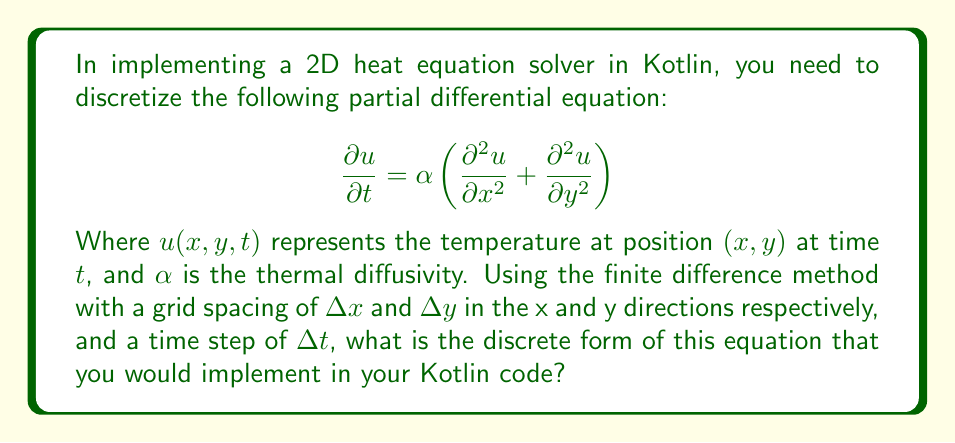Show me your answer to this math problem. To discretize the 2D heat equation, we need to approximate the partial derivatives using finite differences:

1. For the time derivative, we use forward difference:
   $$ \frac{\partial u}{\partial t} \approx \frac{u_{i,j}^{n+1} - u_{i,j}^n}{\Delta t} $$

2. For the spatial derivatives, we use central differences:
   $$ \frac{\partial^2 u}{\partial x^2} \approx \frac{u_{i+1,j}^n - 2u_{i,j}^n + u_{i-1,j}^n}{(\Delta x)^2} $$
   $$ \frac{\partial^2 u}{\partial y^2} \approx \frac{u_{i,j+1}^n - 2u_{i,j}^n + u_{i,j-1}^n}{(\Delta y)^2} $$

3. Substituting these approximations into the original PDE:

   $$ \frac{u_{i,j}^{n+1} - u_{i,j}^n}{\Delta t} = \alpha \left(\frac{u_{i+1,j}^n - 2u_{i,j}^n + u_{i-1,j}^n}{(\Delta x)^2} + \frac{u_{i,j+1}^n - 2u_{i,j}^n + u_{i,j-1}^n}{(\Delta y)^2}\right) $$

4. Rearranging to solve for $u_{i,j}^{n+1}$:

   $$ u_{i,j}^{n+1} = u_{i,j}^n + \alpha \Delta t \left(\frac{u_{i+1,j}^n - 2u_{i,j}^n + u_{i-1,j}^n}{(\Delta x)^2} + \frac{u_{i,j+1}^n - 2u_{i,j}^n + u_{i,j-1}^n}{(\Delta y)^2}\right) $$

This is the discrete form of the 2D heat equation that would be implemented in Kotlin code.
Answer: $$ u_{i,j}^{n+1} = u_{i,j}^n + \alpha \Delta t \left(\frac{u_{i+1,j}^n - 2u_{i,j}^n + u_{i-1,j}^n}{(\Delta x)^2} + \frac{u_{i,j+1}^n - 2u_{i,j}^n + u_{i,j-1}^n}{(\Delta y)^2}\right) $$ 